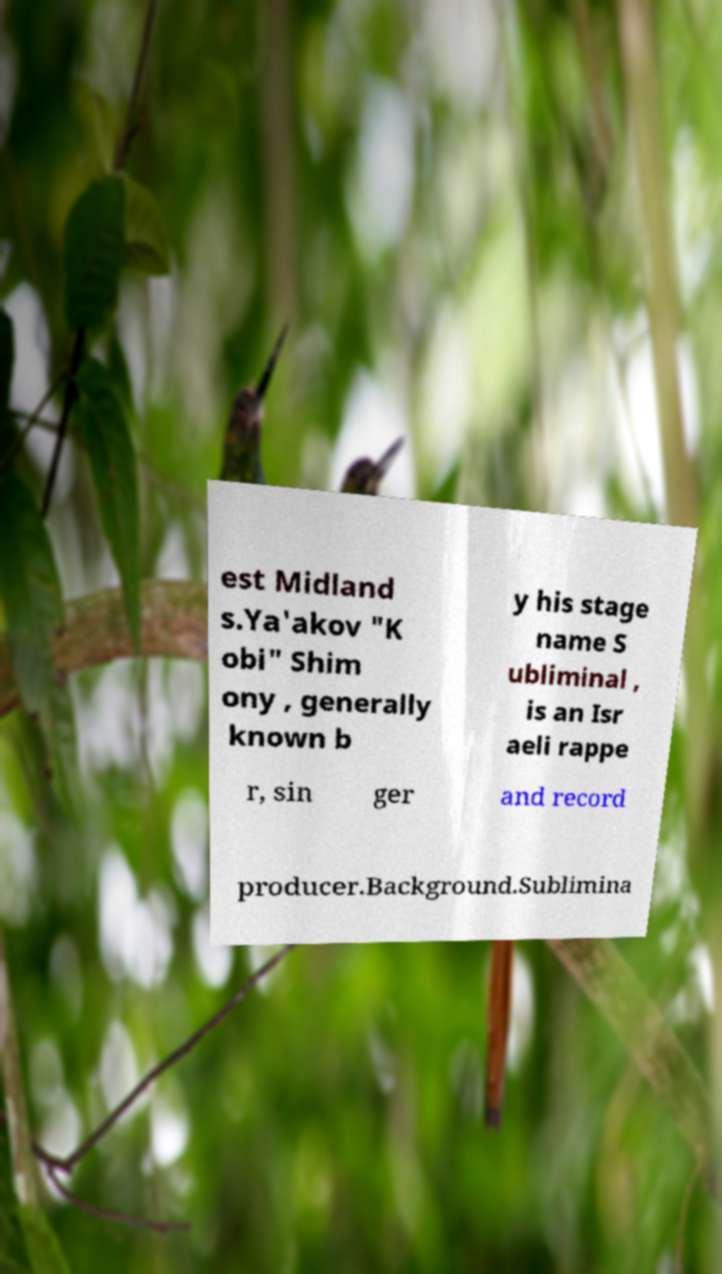What messages or text are displayed in this image? I need them in a readable, typed format. est Midland s.Ya'akov "K obi" Shim ony , generally known b y his stage name S ubliminal , is an Isr aeli rappe r, sin ger and record producer.Background.Sublimina 